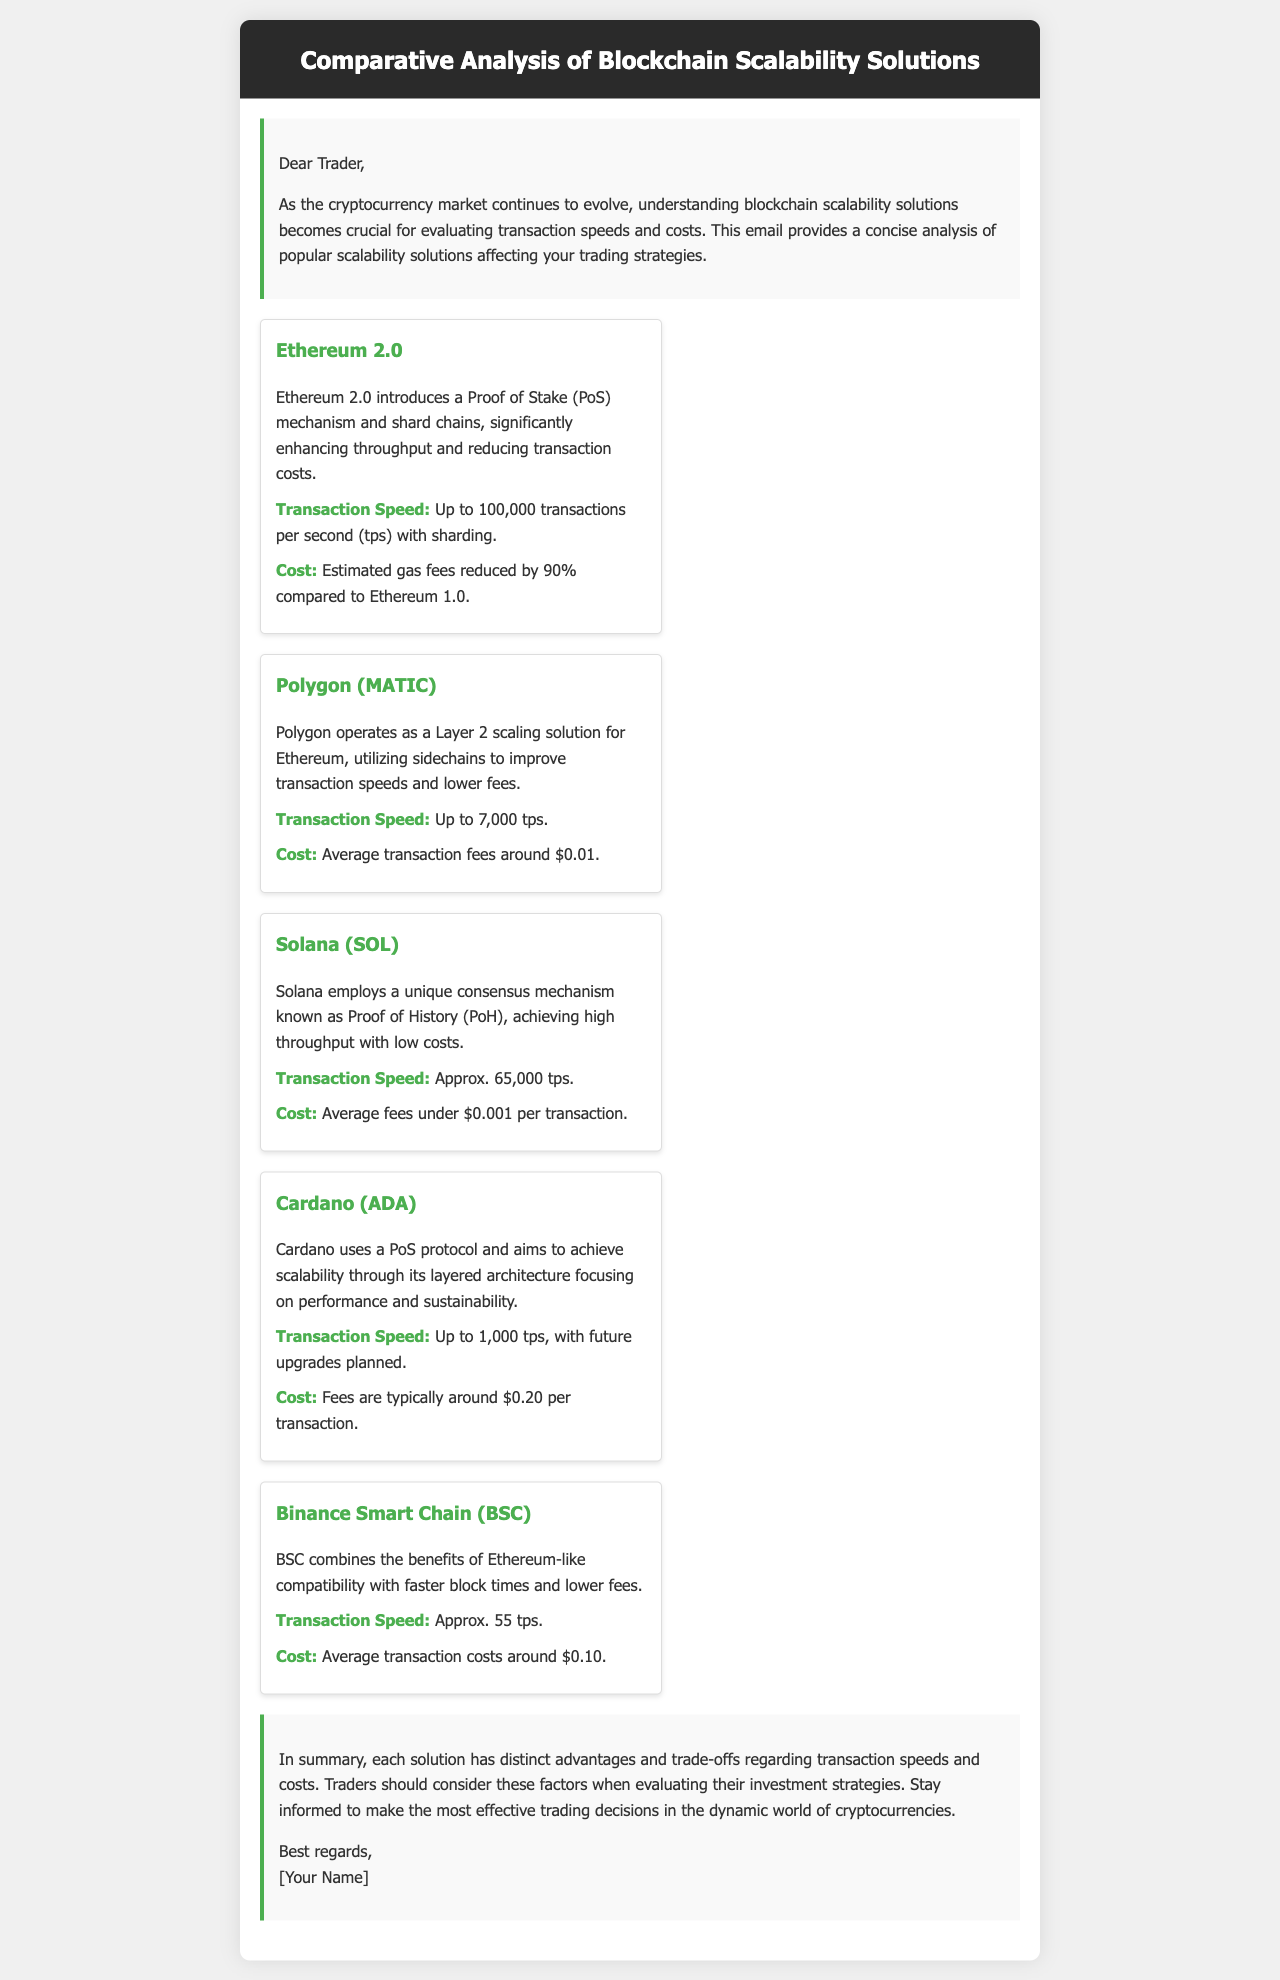what is the main purpose of the email? The email provides a concise analysis of popular scalability solutions affecting trading strategies.
Answer: analysis of scalability solutions what is the transaction speed of Ethereum 2.0? The transaction speed for Ethereum 2.0, as noted in the document, is up to 100,000 transactions per second with sharding.
Answer: 100,000 tps what is the average transaction cost on Solana? The document states that average fees on Solana are under $0.001 per transaction.
Answer: under $0.001 which blockchain uses Proof of History? The document identifies Solana as the blockchain that employs Proof of History as its consensus mechanism.
Answer: Solana what are the estimated gas fees reduced by Ethereum 2.0 compared to Ethereum 1.0? The document specifies that the estimated gas fees for Ethereum 2.0 are reduced by 90% compared to Ethereum 1.0.
Answer: 90% what is unique about Polygon's operation? The document mentions that Polygon operates as a Layer 2 scaling solution for Ethereum, utilizing sidechains.
Answer: Layer 2 scaling solution what transaction speed is expected from Cardano with future upgrades? The document notes that Cardano aims for a transaction speed of up to 1,000 transactions per second, with future upgrades planned.
Answer: up to 1,000 tps what is the average transaction cost on Binance Smart Chain? The document states that average transaction costs on Binance Smart Chain are around $0.10.
Answer: $0.10 